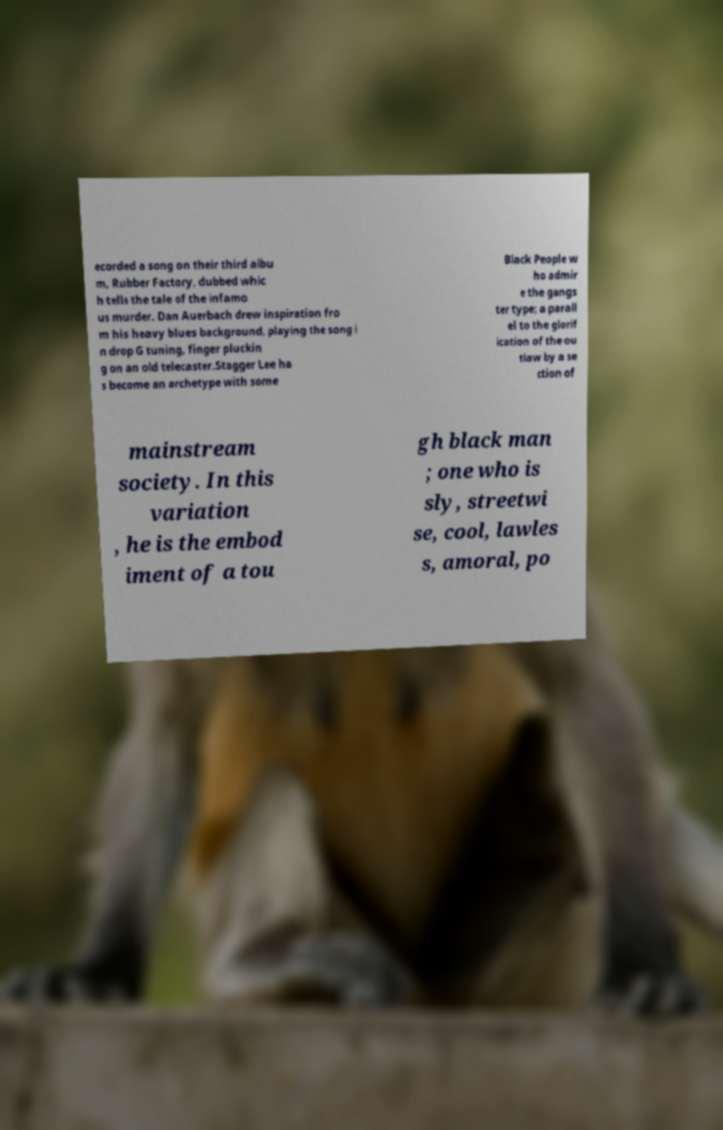Please identify and transcribe the text found in this image. ecorded a song on their third albu m, Rubber Factory, dubbed whic h tells the tale of the infamo us murder. Dan Auerbach drew inspiration fro m his heavy blues background, playing the song i n drop G tuning, finger pluckin g on an old telecaster.Stagger Lee ha s become an archetype with some Black People w ho admir e the gangs ter type; a parall el to the glorif ication of the ou tlaw by a se ction of mainstream society. In this variation , he is the embod iment of a tou gh black man ; one who is sly, streetwi se, cool, lawles s, amoral, po 